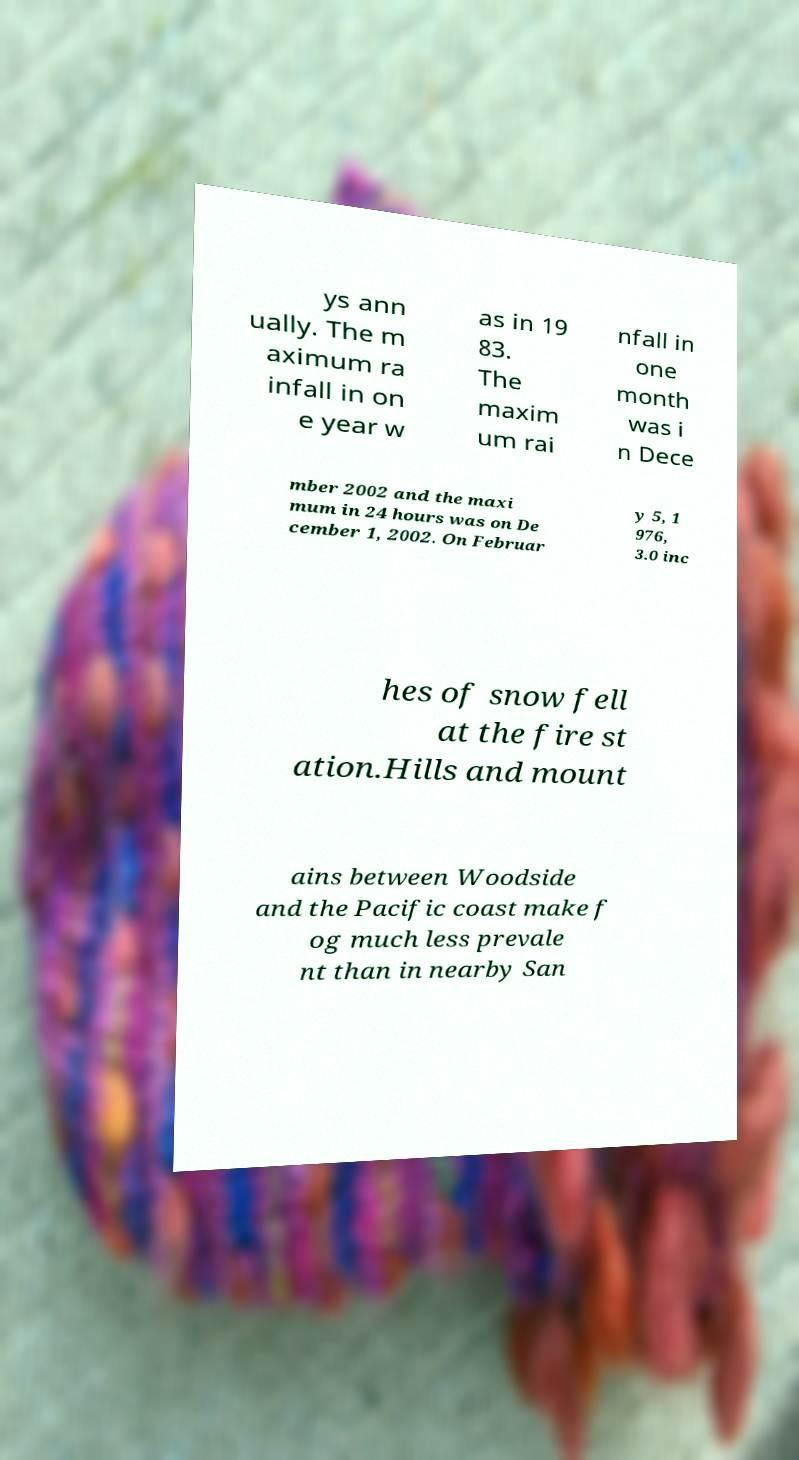Please identify and transcribe the text found in this image. ys ann ually. The m aximum ra infall in on e year w as in 19 83. The maxim um rai nfall in one month was i n Dece mber 2002 and the maxi mum in 24 hours was on De cember 1, 2002. On Februar y 5, 1 976, 3.0 inc hes of snow fell at the fire st ation.Hills and mount ains between Woodside and the Pacific coast make f og much less prevale nt than in nearby San 